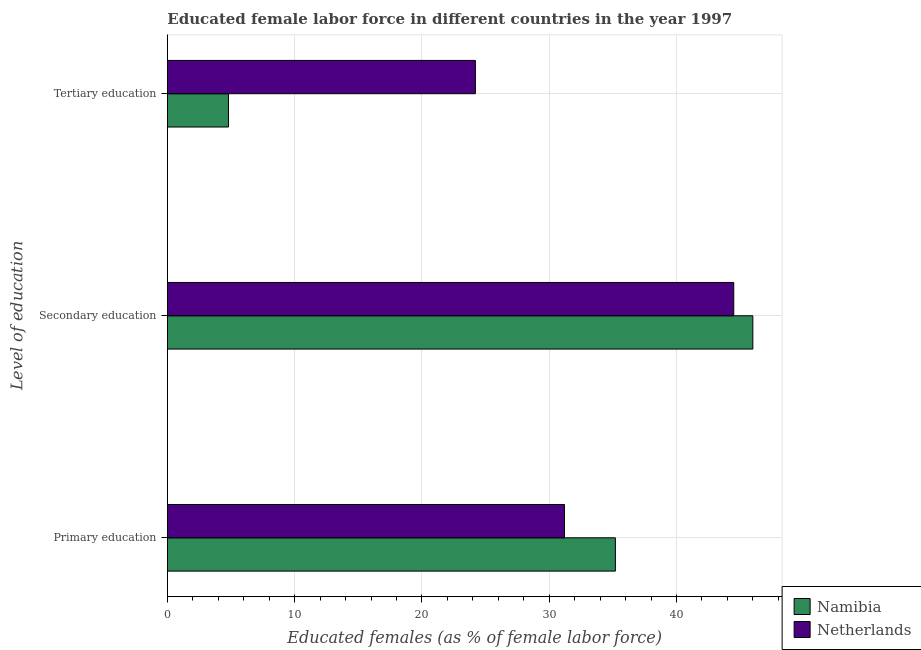How many different coloured bars are there?
Make the answer very short. 2. How many bars are there on the 1st tick from the bottom?
Give a very brief answer. 2. What is the label of the 3rd group of bars from the top?
Make the answer very short. Primary education. What is the percentage of female labor force who received tertiary education in Namibia?
Offer a terse response. 4.8. Across all countries, what is the maximum percentage of female labor force who received tertiary education?
Provide a short and direct response. 24.2. Across all countries, what is the minimum percentage of female labor force who received secondary education?
Your answer should be very brief. 44.5. In which country was the percentage of female labor force who received primary education maximum?
Offer a terse response. Namibia. In which country was the percentage of female labor force who received tertiary education minimum?
Give a very brief answer. Namibia. What is the total percentage of female labor force who received tertiary education in the graph?
Ensure brevity in your answer.  29. What is the difference between the percentage of female labor force who received tertiary education in Namibia and that in Netherlands?
Offer a very short reply. -19.4. What is the difference between the percentage of female labor force who received primary education in Netherlands and the percentage of female labor force who received tertiary education in Namibia?
Provide a short and direct response. 26.4. What is the average percentage of female labor force who received primary education per country?
Ensure brevity in your answer.  33.2. What is the difference between the percentage of female labor force who received secondary education and percentage of female labor force who received primary education in Netherlands?
Offer a very short reply. 13.3. In how many countries, is the percentage of female labor force who received secondary education greater than 22 %?
Keep it short and to the point. 2. What is the ratio of the percentage of female labor force who received primary education in Netherlands to that in Namibia?
Offer a terse response. 0.89. Is the percentage of female labor force who received primary education in Netherlands less than that in Namibia?
Provide a succinct answer. Yes. What is the difference between the highest and the second highest percentage of female labor force who received tertiary education?
Your answer should be very brief. 19.4. What is the difference between the highest and the lowest percentage of female labor force who received primary education?
Ensure brevity in your answer.  4. Is the sum of the percentage of female labor force who received tertiary education in Netherlands and Namibia greater than the maximum percentage of female labor force who received primary education across all countries?
Ensure brevity in your answer.  No. What does the 1st bar from the top in Primary education represents?
Your answer should be compact. Netherlands. What does the 2nd bar from the bottom in Tertiary education represents?
Your answer should be very brief. Netherlands. How many bars are there?
Make the answer very short. 6. Are all the bars in the graph horizontal?
Provide a succinct answer. Yes. How many countries are there in the graph?
Make the answer very short. 2. What is the difference between two consecutive major ticks on the X-axis?
Make the answer very short. 10. Are the values on the major ticks of X-axis written in scientific E-notation?
Make the answer very short. No. Does the graph contain any zero values?
Your response must be concise. No. Does the graph contain grids?
Provide a short and direct response. Yes. How many legend labels are there?
Offer a terse response. 2. How are the legend labels stacked?
Offer a terse response. Vertical. What is the title of the graph?
Give a very brief answer. Educated female labor force in different countries in the year 1997. What is the label or title of the X-axis?
Make the answer very short. Educated females (as % of female labor force). What is the label or title of the Y-axis?
Your response must be concise. Level of education. What is the Educated females (as % of female labor force) of Namibia in Primary education?
Make the answer very short. 35.2. What is the Educated females (as % of female labor force) in Netherlands in Primary education?
Your response must be concise. 31.2. What is the Educated females (as % of female labor force) of Namibia in Secondary education?
Make the answer very short. 46. What is the Educated females (as % of female labor force) in Netherlands in Secondary education?
Your answer should be compact. 44.5. What is the Educated females (as % of female labor force) of Namibia in Tertiary education?
Give a very brief answer. 4.8. What is the Educated females (as % of female labor force) of Netherlands in Tertiary education?
Offer a terse response. 24.2. Across all Level of education, what is the maximum Educated females (as % of female labor force) in Namibia?
Keep it short and to the point. 46. Across all Level of education, what is the maximum Educated females (as % of female labor force) of Netherlands?
Offer a very short reply. 44.5. Across all Level of education, what is the minimum Educated females (as % of female labor force) of Namibia?
Provide a short and direct response. 4.8. Across all Level of education, what is the minimum Educated females (as % of female labor force) of Netherlands?
Provide a short and direct response. 24.2. What is the total Educated females (as % of female labor force) of Namibia in the graph?
Provide a succinct answer. 86. What is the total Educated females (as % of female labor force) of Netherlands in the graph?
Provide a short and direct response. 99.9. What is the difference between the Educated females (as % of female labor force) of Netherlands in Primary education and that in Secondary education?
Make the answer very short. -13.3. What is the difference between the Educated females (as % of female labor force) of Namibia in Primary education and that in Tertiary education?
Your response must be concise. 30.4. What is the difference between the Educated females (as % of female labor force) of Netherlands in Primary education and that in Tertiary education?
Provide a succinct answer. 7. What is the difference between the Educated females (as % of female labor force) of Namibia in Secondary education and that in Tertiary education?
Provide a succinct answer. 41.2. What is the difference between the Educated females (as % of female labor force) of Netherlands in Secondary education and that in Tertiary education?
Your answer should be compact. 20.3. What is the difference between the Educated females (as % of female labor force) in Namibia in Secondary education and the Educated females (as % of female labor force) in Netherlands in Tertiary education?
Your response must be concise. 21.8. What is the average Educated females (as % of female labor force) in Namibia per Level of education?
Provide a short and direct response. 28.67. What is the average Educated females (as % of female labor force) in Netherlands per Level of education?
Make the answer very short. 33.3. What is the difference between the Educated females (as % of female labor force) in Namibia and Educated females (as % of female labor force) in Netherlands in Secondary education?
Offer a terse response. 1.5. What is the difference between the Educated females (as % of female labor force) of Namibia and Educated females (as % of female labor force) of Netherlands in Tertiary education?
Keep it short and to the point. -19.4. What is the ratio of the Educated females (as % of female labor force) of Namibia in Primary education to that in Secondary education?
Keep it short and to the point. 0.77. What is the ratio of the Educated females (as % of female labor force) in Netherlands in Primary education to that in Secondary education?
Offer a terse response. 0.7. What is the ratio of the Educated females (as % of female labor force) of Namibia in Primary education to that in Tertiary education?
Keep it short and to the point. 7.33. What is the ratio of the Educated females (as % of female labor force) in Netherlands in Primary education to that in Tertiary education?
Provide a short and direct response. 1.29. What is the ratio of the Educated females (as % of female labor force) of Namibia in Secondary education to that in Tertiary education?
Your response must be concise. 9.58. What is the ratio of the Educated females (as % of female labor force) of Netherlands in Secondary education to that in Tertiary education?
Keep it short and to the point. 1.84. What is the difference between the highest and the second highest Educated females (as % of female labor force) in Namibia?
Your response must be concise. 10.8. What is the difference between the highest and the second highest Educated females (as % of female labor force) in Netherlands?
Ensure brevity in your answer.  13.3. What is the difference between the highest and the lowest Educated females (as % of female labor force) in Namibia?
Your answer should be very brief. 41.2. What is the difference between the highest and the lowest Educated females (as % of female labor force) in Netherlands?
Your response must be concise. 20.3. 